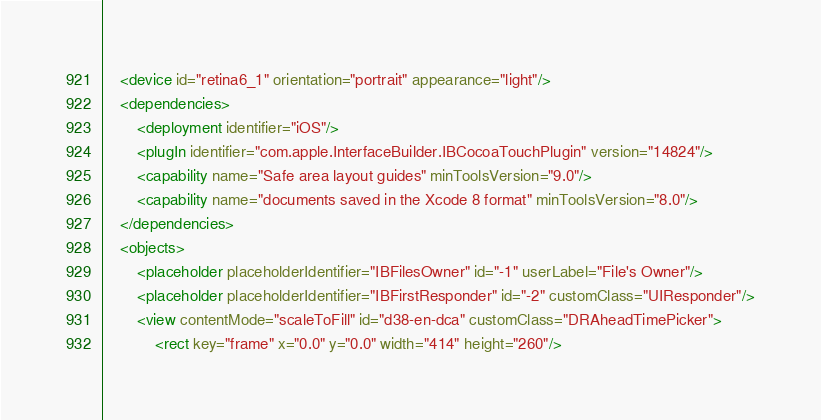Convert code to text. <code><loc_0><loc_0><loc_500><loc_500><_XML_>    <device id="retina6_1" orientation="portrait" appearance="light"/>
    <dependencies>
        <deployment identifier="iOS"/>
        <plugIn identifier="com.apple.InterfaceBuilder.IBCocoaTouchPlugin" version="14824"/>
        <capability name="Safe area layout guides" minToolsVersion="9.0"/>
        <capability name="documents saved in the Xcode 8 format" minToolsVersion="8.0"/>
    </dependencies>
    <objects>
        <placeholder placeholderIdentifier="IBFilesOwner" id="-1" userLabel="File's Owner"/>
        <placeholder placeholderIdentifier="IBFirstResponder" id="-2" customClass="UIResponder"/>
        <view contentMode="scaleToFill" id="d38-en-dca" customClass="DRAheadTimePicker">
            <rect key="frame" x="0.0" y="0.0" width="414" height="260"/></code> 